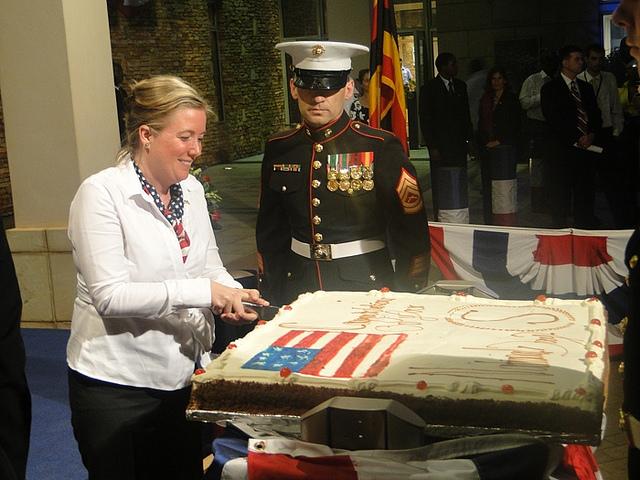What branch of the military does the man belong to?
Write a very short answer. Marines. How many buntings can be seen in the image?
Quick response, please. 2. What is depicted on the cake?
Quick response, please. Flag. What event might be taking place here?
Short answer required. Birthday. What is the name of what they are wearing?
Give a very brief answer. Uniform. 